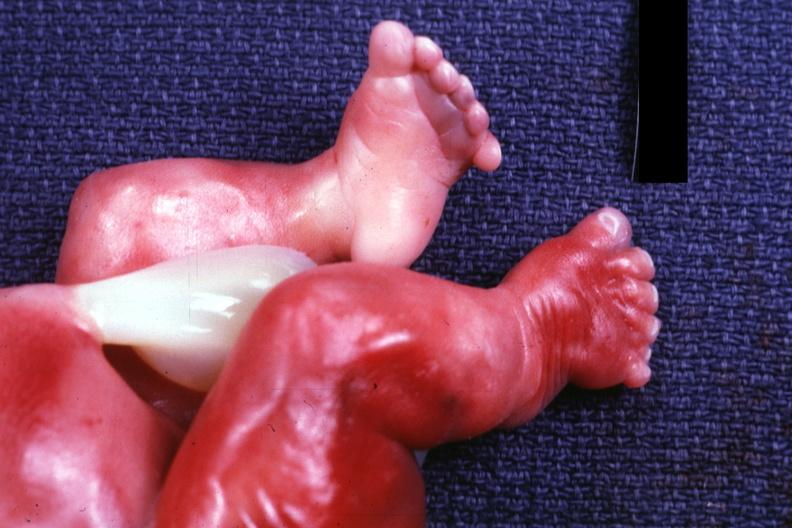re good example tastefully shown with face out of picture and genitalia too short?
Answer the question using a single word or phrase. No 